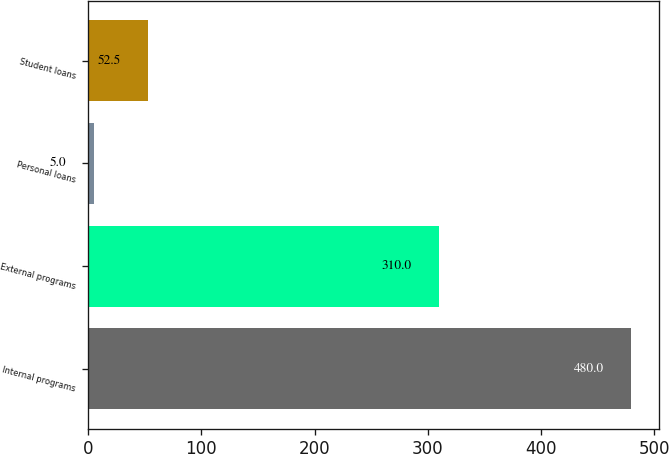Convert chart to OTSL. <chart><loc_0><loc_0><loc_500><loc_500><bar_chart><fcel>Internal programs<fcel>External programs<fcel>Personal loans<fcel>Student loans<nl><fcel>480<fcel>310<fcel>5<fcel>52.5<nl></chart> 